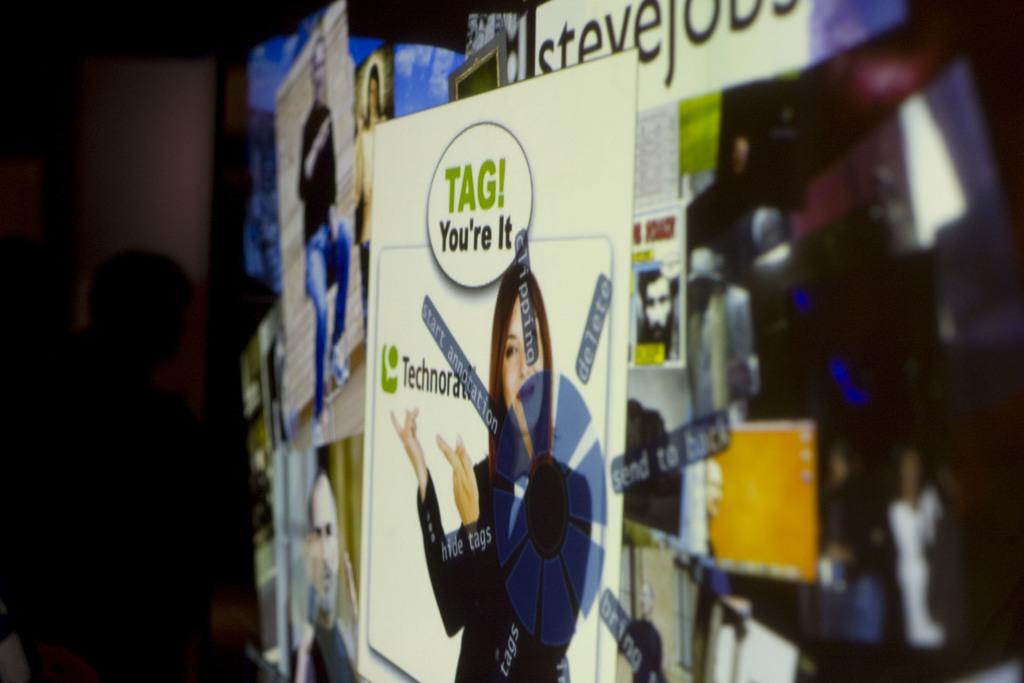Who is it?
Your answer should be compact. You are. What is the company on the advertisement?
Your answer should be very brief. Technorati. 